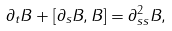Convert formula to latex. <formula><loc_0><loc_0><loc_500><loc_500>\partial _ { t } B + [ \partial _ { s } B , B ] = \partial ^ { 2 } _ { s s } B ,</formula> 